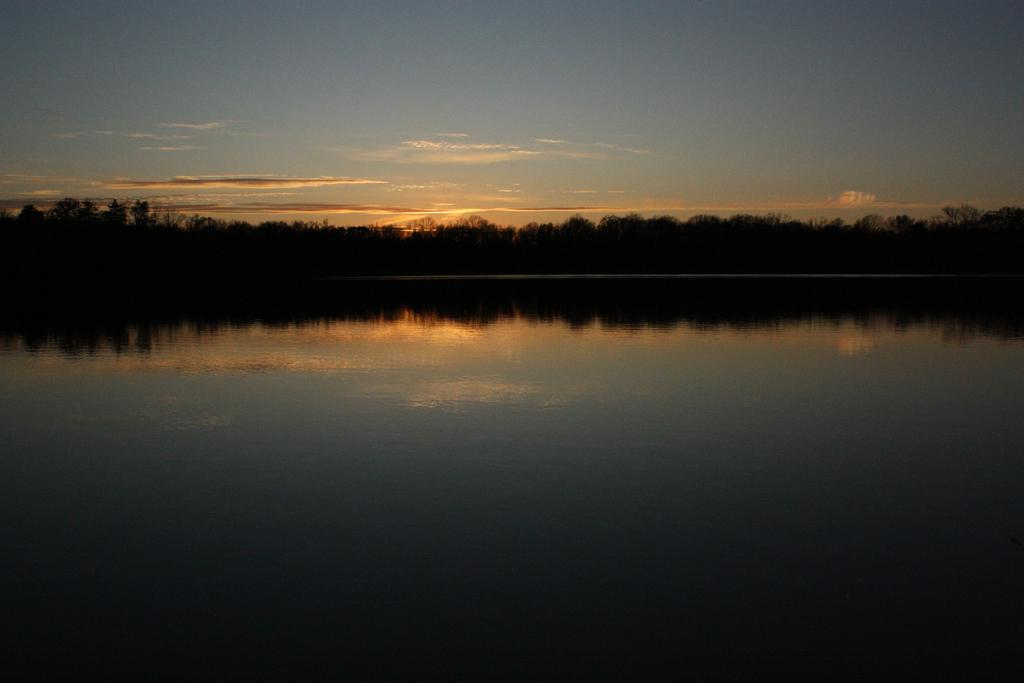What is the main object in the picture? There is a pot in the picture. What can be seen around the pot? Trees are visible around the pot. How would you describe the sky in the image? The sky is clouded in the image. What type of cream is being used to fertilize the plant in the image? There is no plant or cream present in the image; it features a pot with trees visible around it. 